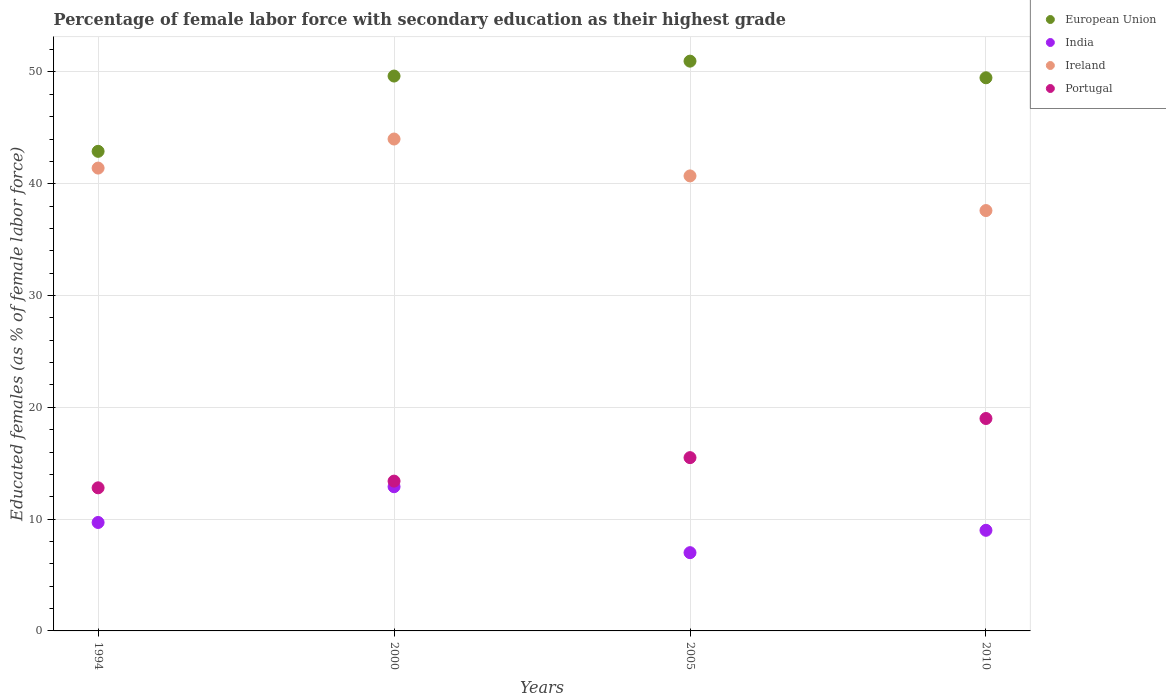What is the percentage of female labor force with secondary education in Portugal in 2010?
Your answer should be very brief. 19. Across all years, what is the minimum percentage of female labor force with secondary education in European Union?
Your response must be concise. 42.9. In which year was the percentage of female labor force with secondary education in European Union maximum?
Your answer should be very brief. 2005. What is the total percentage of female labor force with secondary education in Ireland in the graph?
Your answer should be very brief. 163.7. What is the difference between the percentage of female labor force with secondary education in European Union in 2000 and that in 2005?
Make the answer very short. -1.33. What is the difference between the percentage of female labor force with secondary education in India in 2000 and the percentage of female labor force with secondary education in European Union in 2010?
Provide a succinct answer. -36.58. What is the average percentage of female labor force with secondary education in Portugal per year?
Keep it short and to the point. 15.17. In the year 2000, what is the difference between the percentage of female labor force with secondary education in Ireland and percentage of female labor force with secondary education in European Union?
Provide a succinct answer. -5.63. In how many years, is the percentage of female labor force with secondary education in India greater than 8 %?
Give a very brief answer. 3. What is the ratio of the percentage of female labor force with secondary education in Ireland in 2000 to that in 2010?
Offer a terse response. 1.17. What is the difference between the highest and the second highest percentage of female labor force with secondary education in Ireland?
Keep it short and to the point. 2.6. What is the difference between the highest and the lowest percentage of female labor force with secondary education in Portugal?
Your answer should be very brief. 6.2. Is the sum of the percentage of female labor force with secondary education in India in 1994 and 2010 greater than the maximum percentage of female labor force with secondary education in European Union across all years?
Offer a terse response. No. Does the percentage of female labor force with secondary education in Portugal monotonically increase over the years?
Offer a terse response. Yes. How many dotlines are there?
Make the answer very short. 4. What is the difference between two consecutive major ticks on the Y-axis?
Make the answer very short. 10. Does the graph contain any zero values?
Your answer should be compact. No. How are the legend labels stacked?
Offer a terse response. Vertical. What is the title of the graph?
Give a very brief answer. Percentage of female labor force with secondary education as their highest grade. Does "Puerto Rico" appear as one of the legend labels in the graph?
Your response must be concise. No. What is the label or title of the Y-axis?
Make the answer very short. Educated females (as % of female labor force). What is the Educated females (as % of female labor force) in European Union in 1994?
Provide a short and direct response. 42.9. What is the Educated females (as % of female labor force) of India in 1994?
Provide a short and direct response. 9.7. What is the Educated females (as % of female labor force) in Ireland in 1994?
Your response must be concise. 41.4. What is the Educated females (as % of female labor force) of Portugal in 1994?
Your answer should be compact. 12.8. What is the Educated females (as % of female labor force) of European Union in 2000?
Offer a terse response. 49.63. What is the Educated females (as % of female labor force) of India in 2000?
Offer a very short reply. 12.9. What is the Educated females (as % of female labor force) of Portugal in 2000?
Offer a terse response. 13.4. What is the Educated females (as % of female labor force) in European Union in 2005?
Your answer should be compact. 50.97. What is the Educated females (as % of female labor force) in Ireland in 2005?
Provide a short and direct response. 40.7. What is the Educated females (as % of female labor force) in Portugal in 2005?
Provide a succinct answer. 15.5. What is the Educated females (as % of female labor force) of European Union in 2010?
Give a very brief answer. 49.48. What is the Educated females (as % of female labor force) of Ireland in 2010?
Ensure brevity in your answer.  37.6. Across all years, what is the maximum Educated females (as % of female labor force) of European Union?
Make the answer very short. 50.97. Across all years, what is the maximum Educated females (as % of female labor force) of India?
Make the answer very short. 12.9. Across all years, what is the maximum Educated females (as % of female labor force) in Portugal?
Give a very brief answer. 19. Across all years, what is the minimum Educated females (as % of female labor force) of European Union?
Offer a very short reply. 42.9. Across all years, what is the minimum Educated females (as % of female labor force) in India?
Your answer should be very brief. 7. Across all years, what is the minimum Educated females (as % of female labor force) in Ireland?
Your answer should be very brief. 37.6. Across all years, what is the minimum Educated females (as % of female labor force) of Portugal?
Your response must be concise. 12.8. What is the total Educated females (as % of female labor force) of European Union in the graph?
Your answer should be compact. 192.98. What is the total Educated females (as % of female labor force) in India in the graph?
Provide a short and direct response. 38.6. What is the total Educated females (as % of female labor force) of Ireland in the graph?
Keep it short and to the point. 163.7. What is the total Educated females (as % of female labor force) in Portugal in the graph?
Your answer should be very brief. 60.7. What is the difference between the Educated females (as % of female labor force) of European Union in 1994 and that in 2000?
Offer a terse response. -6.73. What is the difference between the Educated females (as % of female labor force) in Ireland in 1994 and that in 2000?
Offer a terse response. -2.6. What is the difference between the Educated females (as % of female labor force) in Portugal in 1994 and that in 2000?
Your response must be concise. -0.6. What is the difference between the Educated females (as % of female labor force) in European Union in 1994 and that in 2005?
Your answer should be compact. -8.07. What is the difference between the Educated females (as % of female labor force) of India in 1994 and that in 2005?
Offer a very short reply. 2.7. What is the difference between the Educated females (as % of female labor force) in European Union in 1994 and that in 2010?
Keep it short and to the point. -6.58. What is the difference between the Educated females (as % of female labor force) of India in 1994 and that in 2010?
Your answer should be very brief. 0.7. What is the difference between the Educated females (as % of female labor force) in Ireland in 1994 and that in 2010?
Ensure brevity in your answer.  3.8. What is the difference between the Educated females (as % of female labor force) in European Union in 2000 and that in 2005?
Provide a succinct answer. -1.33. What is the difference between the Educated females (as % of female labor force) in Portugal in 2000 and that in 2005?
Keep it short and to the point. -2.1. What is the difference between the Educated females (as % of female labor force) of European Union in 2000 and that in 2010?
Offer a terse response. 0.15. What is the difference between the Educated females (as % of female labor force) in India in 2000 and that in 2010?
Your answer should be very brief. 3.9. What is the difference between the Educated females (as % of female labor force) of Ireland in 2000 and that in 2010?
Your answer should be compact. 6.4. What is the difference between the Educated females (as % of female labor force) of European Union in 2005 and that in 2010?
Ensure brevity in your answer.  1.49. What is the difference between the Educated females (as % of female labor force) of Ireland in 2005 and that in 2010?
Make the answer very short. 3.1. What is the difference between the Educated females (as % of female labor force) in European Union in 1994 and the Educated females (as % of female labor force) in India in 2000?
Make the answer very short. 30. What is the difference between the Educated females (as % of female labor force) of European Union in 1994 and the Educated females (as % of female labor force) of Ireland in 2000?
Make the answer very short. -1.1. What is the difference between the Educated females (as % of female labor force) in European Union in 1994 and the Educated females (as % of female labor force) in Portugal in 2000?
Your answer should be compact. 29.5. What is the difference between the Educated females (as % of female labor force) of India in 1994 and the Educated females (as % of female labor force) of Ireland in 2000?
Offer a very short reply. -34.3. What is the difference between the Educated females (as % of female labor force) of India in 1994 and the Educated females (as % of female labor force) of Portugal in 2000?
Offer a very short reply. -3.7. What is the difference between the Educated females (as % of female labor force) in Ireland in 1994 and the Educated females (as % of female labor force) in Portugal in 2000?
Provide a succinct answer. 28. What is the difference between the Educated females (as % of female labor force) of European Union in 1994 and the Educated females (as % of female labor force) of India in 2005?
Give a very brief answer. 35.9. What is the difference between the Educated females (as % of female labor force) of European Union in 1994 and the Educated females (as % of female labor force) of Ireland in 2005?
Provide a short and direct response. 2.2. What is the difference between the Educated females (as % of female labor force) of European Union in 1994 and the Educated females (as % of female labor force) of Portugal in 2005?
Keep it short and to the point. 27.4. What is the difference between the Educated females (as % of female labor force) of India in 1994 and the Educated females (as % of female labor force) of Ireland in 2005?
Your answer should be compact. -31. What is the difference between the Educated females (as % of female labor force) of India in 1994 and the Educated females (as % of female labor force) of Portugal in 2005?
Give a very brief answer. -5.8. What is the difference between the Educated females (as % of female labor force) of Ireland in 1994 and the Educated females (as % of female labor force) of Portugal in 2005?
Your answer should be very brief. 25.9. What is the difference between the Educated females (as % of female labor force) of European Union in 1994 and the Educated females (as % of female labor force) of India in 2010?
Your answer should be compact. 33.9. What is the difference between the Educated females (as % of female labor force) in European Union in 1994 and the Educated females (as % of female labor force) in Ireland in 2010?
Give a very brief answer. 5.3. What is the difference between the Educated females (as % of female labor force) of European Union in 1994 and the Educated females (as % of female labor force) of Portugal in 2010?
Provide a succinct answer. 23.9. What is the difference between the Educated females (as % of female labor force) of India in 1994 and the Educated females (as % of female labor force) of Ireland in 2010?
Keep it short and to the point. -27.9. What is the difference between the Educated females (as % of female labor force) of India in 1994 and the Educated females (as % of female labor force) of Portugal in 2010?
Your response must be concise. -9.3. What is the difference between the Educated females (as % of female labor force) in Ireland in 1994 and the Educated females (as % of female labor force) in Portugal in 2010?
Your answer should be very brief. 22.4. What is the difference between the Educated females (as % of female labor force) in European Union in 2000 and the Educated females (as % of female labor force) in India in 2005?
Ensure brevity in your answer.  42.63. What is the difference between the Educated females (as % of female labor force) of European Union in 2000 and the Educated females (as % of female labor force) of Ireland in 2005?
Offer a very short reply. 8.93. What is the difference between the Educated females (as % of female labor force) in European Union in 2000 and the Educated females (as % of female labor force) in Portugal in 2005?
Ensure brevity in your answer.  34.13. What is the difference between the Educated females (as % of female labor force) of India in 2000 and the Educated females (as % of female labor force) of Ireland in 2005?
Make the answer very short. -27.8. What is the difference between the Educated females (as % of female labor force) in India in 2000 and the Educated females (as % of female labor force) in Portugal in 2005?
Your response must be concise. -2.6. What is the difference between the Educated females (as % of female labor force) of European Union in 2000 and the Educated females (as % of female labor force) of India in 2010?
Provide a succinct answer. 40.63. What is the difference between the Educated females (as % of female labor force) of European Union in 2000 and the Educated females (as % of female labor force) of Ireland in 2010?
Provide a short and direct response. 12.03. What is the difference between the Educated females (as % of female labor force) of European Union in 2000 and the Educated females (as % of female labor force) of Portugal in 2010?
Give a very brief answer. 30.63. What is the difference between the Educated females (as % of female labor force) of India in 2000 and the Educated females (as % of female labor force) of Ireland in 2010?
Your response must be concise. -24.7. What is the difference between the Educated females (as % of female labor force) in Ireland in 2000 and the Educated females (as % of female labor force) in Portugal in 2010?
Offer a terse response. 25. What is the difference between the Educated females (as % of female labor force) of European Union in 2005 and the Educated females (as % of female labor force) of India in 2010?
Provide a succinct answer. 41.97. What is the difference between the Educated females (as % of female labor force) in European Union in 2005 and the Educated females (as % of female labor force) in Ireland in 2010?
Provide a succinct answer. 13.37. What is the difference between the Educated females (as % of female labor force) of European Union in 2005 and the Educated females (as % of female labor force) of Portugal in 2010?
Your response must be concise. 31.97. What is the difference between the Educated females (as % of female labor force) of India in 2005 and the Educated females (as % of female labor force) of Ireland in 2010?
Ensure brevity in your answer.  -30.6. What is the difference between the Educated females (as % of female labor force) of India in 2005 and the Educated females (as % of female labor force) of Portugal in 2010?
Offer a terse response. -12. What is the difference between the Educated females (as % of female labor force) of Ireland in 2005 and the Educated females (as % of female labor force) of Portugal in 2010?
Keep it short and to the point. 21.7. What is the average Educated females (as % of female labor force) of European Union per year?
Your response must be concise. 48.24. What is the average Educated females (as % of female labor force) of India per year?
Keep it short and to the point. 9.65. What is the average Educated females (as % of female labor force) in Ireland per year?
Offer a very short reply. 40.92. What is the average Educated females (as % of female labor force) in Portugal per year?
Provide a short and direct response. 15.18. In the year 1994, what is the difference between the Educated females (as % of female labor force) of European Union and Educated females (as % of female labor force) of India?
Keep it short and to the point. 33.2. In the year 1994, what is the difference between the Educated females (as % of female labor force) in European Union and Educated females (as % of female labor force) in Ireland?
Your answer should be very brief. 1.5. In the year 1994, what is the difference between the Educated females (as % of female labor force) of European Union and Educated females (as % of female labor force) of Portugal?
Provide a short and direct response. 30.1. In the year 1994, what is the difference between the Educated females (as % of female labor force) in India and Educated females (as % of female labor force) in Ireland?
Provide a succinct answer. -31.7. In the year 1994, what is the difference between the Educated females (as % of female labor force) of India and Educated females (as % of female labor force) of Portugal?
Make the answer very short. -3.1. In the year 1994, what is the difference between the Educated females (as % of female labor force) in Ireland and Educated females (as % of female labor force) in Portugal?
Make the answer very short. 28.6. In the year 2000, what is the difference between the Educated females (as % of female labor force) of European Union and Educated females (as % of female labor force) of India?
Provide a short and direct response. 36.73. In the year 2000, what is the difference between the Educated females (as % of female labor force) of European Union and Educated females (as % of female labor force) of Ireland?
Ensure brevity in your answer.  5.63. In the year 2000, what is the difference between the Educated females (as % of female labor force) in European Union and Educated females (as % of female labor force) in Portugal?
Keep it short and to the point. 36.23. In the year 2000, what is the difference between the Educated females (as % of female labor force) in India and Educated females (as % of female labor force) in Ireland?
Provide a short and direct response. -31.1. In the year 2000, what is the difference between the Educated females (as % of female labor force) in Ireland and Educated females (as % of female labor force) in Portugal?
Make the answer very short. 30.6. In the year 2005, what is the difference between the Educated females (as % of female labor force) in European Union and Educated females (as % of female labor force) in India?
Give a very brief answer. 43.97. In the year 2005, what is the difference between the Educated females (as % of female labor force) in European Union and Educated females (as % of female labor force) in Ireland?
Your answer should be very brief. 10.27. In the year 2005, what is the difference between the Educated females (as % of female labor force) of European Union and Educated females (as % of female labor force) of Portugal?
Offer a terse response. 35.47. In the year 2005, what is the difference between the Educated females (as % of female labor force) in India and Educated females (as % of female labor force) in Ireland?
Keep it short and to the point. -33.7. In the year 2005, what is the difference between the Educated females (as % of female labor force) of Ireland and Educated females (as % of female labor force) of Portugal?
Your answer should be compact. 25.2. In the year 2010, what is the difference between the Educated females (as % of female labor force) in European Union and Educated females (as % of female labor force) in India?
Offer a terse response. 40.48. In the year 2010, what is the difference between the Educated females (as % of female labor force) in European Union and Educated females (as % of female labor force) in Ireland?
Give a very brief answer. 11.88. In the year 2010, what is the difference between the Educated females (as % of female labor force) of European Union and Educated females (as % of female labor force) of Portugal?
Ensure brevity in your answer.  30.48. In the year 2010, what is the difference between the Educated females (as % of female labor force) in India and Educated females (as % of female labor force) in Ireland?
Your response must be concise. -28.6. In the year 2010, what is the difference between the Educated females (as % of female labor force) in India and Educated females (as % of female labor force) in Portugal?
Provide a succinct answer. -10. What is the ratio of the Educated females (as % of female labor force) in European Union in 1994 to that in 2000?
Your response must be concise. 0.86. What is the ratio of the Educated females (as % of female labor force) of India in 1994 to that in 2000?
Your response must be concise. 0.75. What is the ratio of the Educated females (as % of female labor force) in Ireland in 1994 to that in 2000?
Your answer should be very brief. 0.94. What is the ratio of the Educated females (as % of female labor force) in Portugal in 1994 to that in 2000?
Your answer should be compact. 0.96. What is the ratio of the Educated females (as % of female labor force) of European Union in 1994 to that in 2005?
Provide a succinct answer. 0.84. What is the ratio of the Educated females (as % of female labor force) in India in 1994 to that in 2005?
Offer a terse response. 1.39. What is the ratio of the Educated females (as % of female labor force) in Ireland in 1994 to that in 2005?
Your response must be concise. 1.02. What is the ratio of the Educated females (as % of female labor force) in Portugal in 1994 to that in 2005?
Provide a succinct answer. 0.83. What is the ratio of the Educated females (as % of female labor force) in European Union in 1994 to that in 2010?
Your answer should be very brief. 0.87. What is the ratio of the Educated females (as % of female labor force) of India in 1994 to that in 2010?
Your answer should be very brief. 1.08. What is the ratio of the Educated females (as % of female labor force) in Ireland in 1994 to that in 2010?
Offer a very short reply. 1.1. What is the ratio of the Educated females (as % of female labor force) in Portugal in 1994 to that in 2010?
Ensure brevity in your answer.  0.67. What is the ratio of the Educated females (as % of female labor force) of European Union in 2000 to that in 2005?
Keep it short and to the point. 0.97. What is the ratio of the Educated females (as % of female labor force) of India in 2000 to that in 2005?
Give a very brief answer. 1.84. What is the ratio of the Educated females (as % of female labor force) in Ireland in 2000 to that in 2005?
Give a very brief answer. 1.08. What is the ratio of the Educated females (as % of female labor force) of Portugal in 2000 to that in 2005?
Provide a succinct answer. 0.86. What is the ratio of the Educated females (as % of female labor force) of European Union in 2000 to that in 2010?
Ensure brevity in your answer.  1. What is the ratio of the Educated females (as % of female labor force) in India in 2000 to that in 2010?
Offer a very short reply. 1.43. What is the ratio of the Educated females (as % of female labor force) in Ireland in 2000 to that in 2010?
Ensure brevity in your answer.  1.17. What is the ratio of the Educated females (as % of female labor force) in Portugal in 2000 to that in 2010?
Your answer should be very brief. 0.71. What is the ratio of the Educated females (as % of female labor force) in European Union in 2005 to that in 2010?
Give a very brief answer. 1.03. What is the ratio of the Educated females (as % of female labor force) in India in 2005 to that in 2010?
Ensure brevity in your answer.  0.78. What is the ratio of the Educated females (as % of female labor force) of Ireland in 2005 to that in 2010?
Give a very brief answer. 1.08. What is the ratio of the Educated females (as % of female labor force) of Portugal in 2005 to that in 2010?
Offer a terse response. 0.82. What is the difference between the highest and the second highest Educated females (as % of female labor force) of European Union?
Your answer should be compact. 1.33. What is the difference between the highest and the second highest Educated females (as % of female labor force) of India?
Make the answer very short. 3.2. What is the difference between the highest and the second highest Educated females (as % of female labor force) in Ireland?
Your answer should be very brief. 2.6. What is the difference between the highest and the second highest Educated females (as % of female labor force) of Portugal?
Your answer should be very brief. 3.5. What is the difference between the highest and the lowest Educated females (as % of female labor force) in European Union?
Your answer should be very brief. 8.07. What is the difference between the highest and the lowest Educated females (as % of female labor force) in India?
Offer a very short reply. 5.9. What is the difference between the highest and the lowest Educated females (as % of female labor force) in Ireland?
Your response must be concise. 6.4. What is the difference between the highest and the lowest Educated females (as % of female labor force) in Portugal?
Provide a succinct answer. 6.2. 